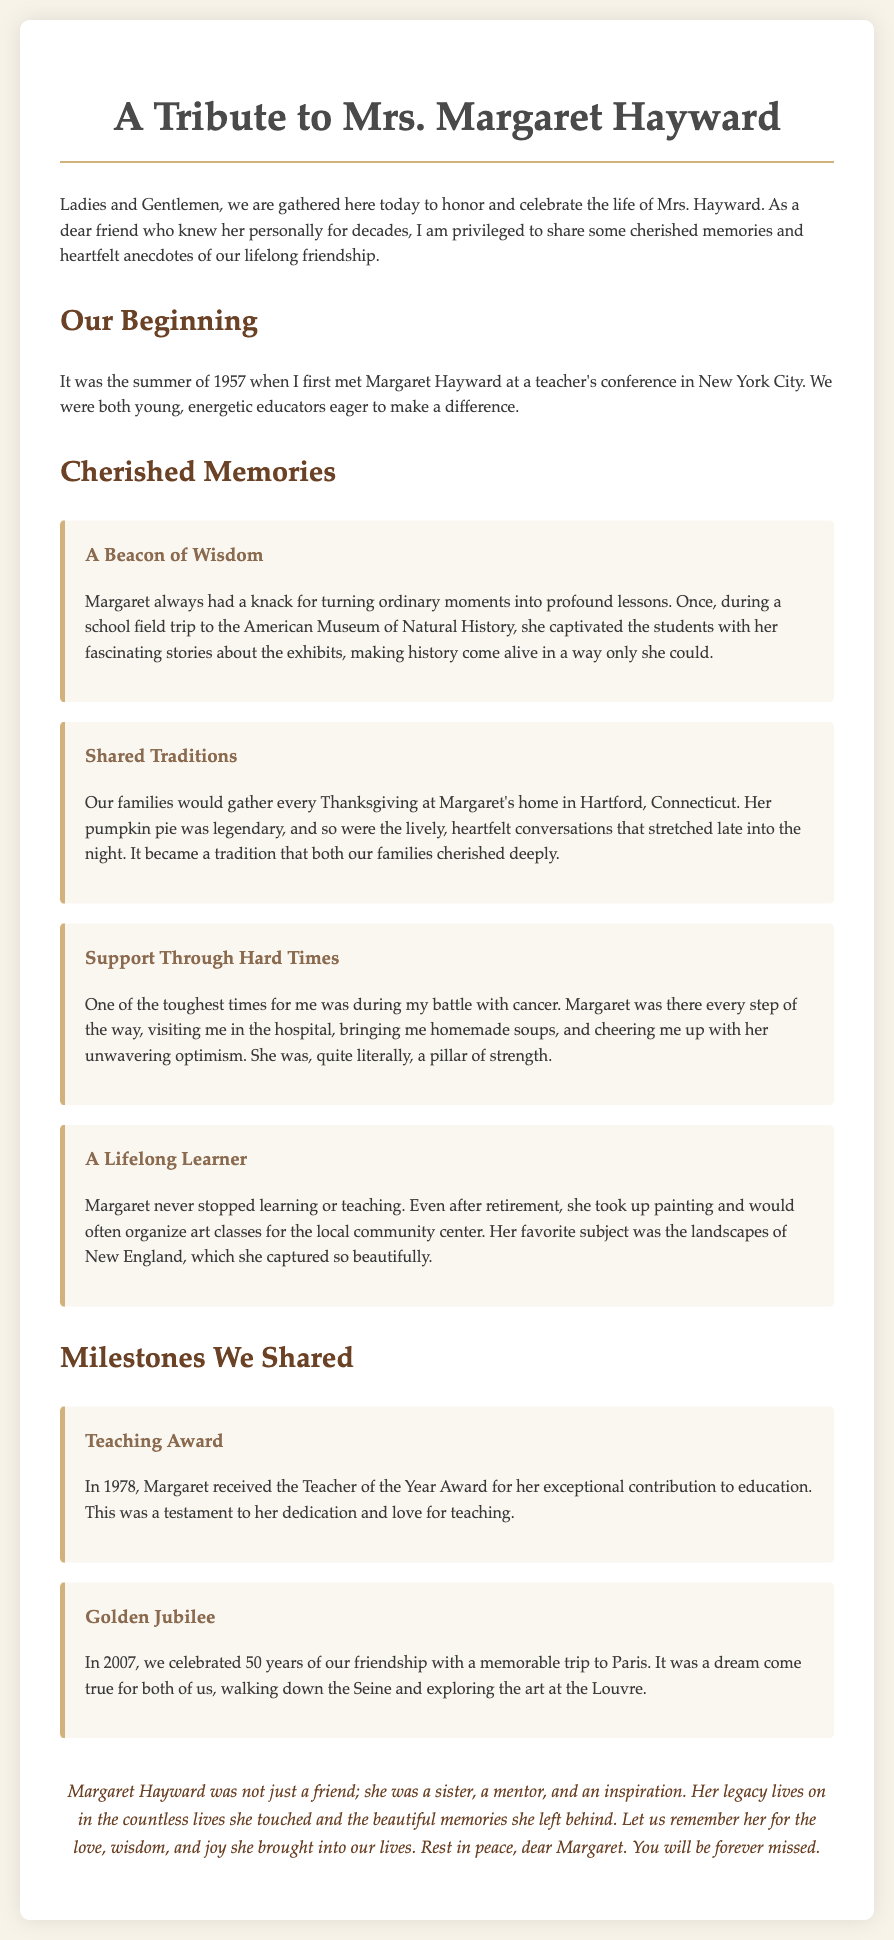What year did the speaker first meet Margaret Hayward? The speaker met Margaret Hayward in the summer of 1957 during a teacher's conference.
Answer: 1957 What was Margaret's legendary dish at Thanksgiving? The document mentions Margaret's pumpkin pie as legendary when her family gathered for Thanksgiving.
Answer: Pumpkin pie What did Margaret receive in 1978? The document states that Margaret received the Teacher of the Year Award for her exceptional contribution to education in 1978.
Answer: Teacher of the Year Award In what year did the speaker celebrate 50 years of friendship with Margaret? The document specifies that the speaker celebrated 50 years of friendship with Margaret in 2007.
Answer: 2007 What was one way Margaret supported the speaker during tough times? The document describes how Margaret visited the speaker in the hospital and brought homemade soups.
Answer: Homemade soups Why was Margaret considered a lifelong learner? The text highlights that even after retirement, Margaret took up painting and organized art classes, showing her commitment to learning.
Answer: Painting and art classes What major milestone did the speaker and Margaret commemorate in Paris? The document mentions that they celebrated 50 years of friendship with a memorable trip to Paris, exploring significant locations.
Answer: Trip to Paris What is a key theme of the conclusion in the document? The conclusion emphasizes that Margaret was a sister, mentor, and inspiration, highlighting her lasting impact on others.
Answer: Legacy What type of events did the speaker and Margaret have every Thanksgiving? The document refers to the gatherings of both families at Margaret's home for Thanksgiving as a cherished tradition.
Answer: Gatherings 